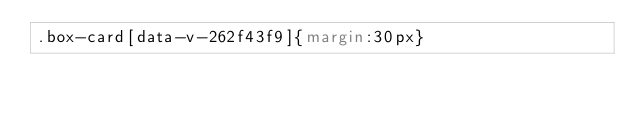<code> <loc_0><loc_0><loc_500><loc_500><_CSS_>.box-card[data-v-262f43f9]{margin:30px}</code> 